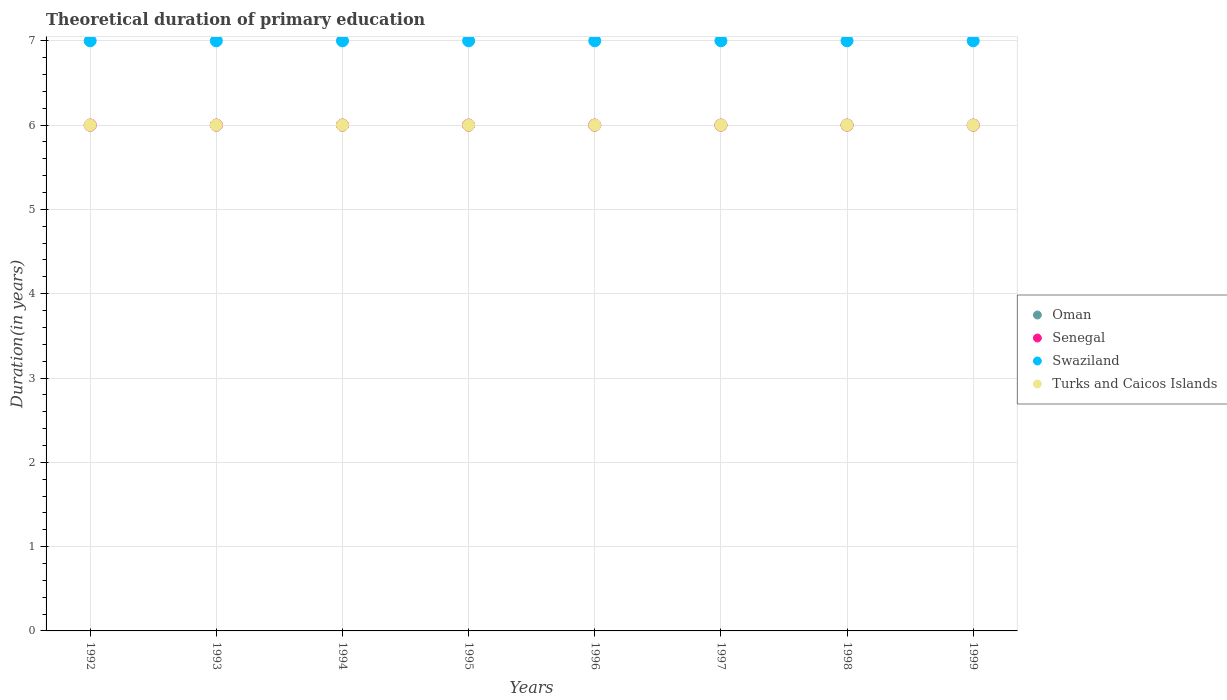What is the total theoretical duration of primary education in Turks and Caicos Islands in 1998?
Give a very brief answer. 6. Across all years, what is the maximum total theoretical duration of primary education in Swaziland?
Ensure brevity in your answer.  7. In which year was the total theoretical duration of primary education in Swaziland maximum?
Make the answer very short. 1992. What is the total total theoretical duration of primary education in Oman in the graph?
Offer a very short reply. 48. What is the difference between the total theoretical duration of primary education in Swaziland in 1992 and the total theoretical duration of primary education in Oman in 1996?
Your answer should be compact. 1. Is the total theoretical duration of primary education in Senegal in 1994 less than that in 1995?
Your answer should be compact. No. What is the difference between the highest and the second highest total theoretical duration of primary education in Senegal?
Offer a terse response. 0. What is the difference between the highest and the lowest total theoretical duration of primary education in Senegal?
Your response must be concise. 0. In how many years, is the total theoretical duration of primary education in Senegal greater than the average total theoretical duration of primary education in Senegal taken over all years?
Your answer should be compact. 0. Is the total theoretical duration of primary education in Swaziland strictly less than the total theoretical duration of primary education in Oman over the years?
Provide a short and direct response. No. How many dotlines are there?
Your answer should be compact. 4. What is the difference between two consecutive major ticks on the Y-axis?
Your answer should be very brief. 1. Are the values on the major ticks of Y-axis written in scientific E-notation?
Ensure brevity in your answer.  No. Does the graph contain grids?
Give a very brief answer. Yes. Where does the legend appear in the graph?
Ensure brevity in your answer.  Center right. How many legend labels are there?
Make the answer very short. 4. What is the title of the graph?
Make the answer very short. Theoretical duration of primary education. Does "East Asia (developing only)" appear as one of the legend labels in the graph?
Provide a short and direct response. No. What is the label or title of the X-axis?
Ensure brevity in your answer.  Years. What is the label or title of the Y-axis?
Provide a succinct answer. Duration(in years). What is the Duration(in years) in Senegal in 1992?
Offer a terse response. 6. What is the Duration(in years) in Swaziland in 1992?
Ensure brevity in your answer.  7. What is the Duration(in years) of Turks and Caicos Islands in 1992?
Ensure brevity in your answer.  6. What is the Duration(in years) of Senegal in 1993?
Make the answer very short. 6. What is the Duration(in years) in Turks and Caicos Islands in 1993?
Ensure brevity in your answer.  6. What is the Duration(in years) of Oman in 1994?
Give a very brief answer. 6. What is the Duration(in years) of Senegal in 1994?
Offer a very short reply. 6. What is the Duration(in years) in Swaziland in 1994?
Your answer should be compact. 7. What is the Duration(in years) in Turks and Caicos Islands in 1994?
Make the answer very short. 6. What is the Duration(in years) of Oman in 1995?
Your answer should be compact. 6. What is the Duration(in years) in Turks and Caicos Islands in 1996?
Your answer should be very brief. 6. What is the Duration(in years) of Oman in 1997?
Your answer should be compact. 6. What is the Duration(in years) in Swaziland in 1997?
Make the answer very short. 7. What is the Duration(in years) in Senegal in 1998?
Keep it short and to the point. 6. What is the Duration(in years) of Senegal in 1999?
Offer a very short reply. 6. Across all years, what is the maximum Duration(in years) in Oman?
Your answer should be compact. 6. Across all years, what is the maximum Duration(in years) in Swaziland?
Give a very brief answer. 7. Across all years, what is the maximum Duration(in years) of Turks and Caicos Islands?
Provide a short and direct response. 6. Across all years, what is the minimum Duration(in years) in Oman?
Your response must be concise. 6. Across all years, what is the minimum Duration(in years) of Swaziland?
Provide a short and direct response. 7. Across all years, what is the minimum Duration(in years) in Turks and Caicos Islands?
Keep it short and to the point. 6. What is the total Duration(in years) in Senegal in the graph?
Make the answer very short. 48. What is the difference between the Duration(in years) of Senegal in 1992 and that in 1993?
Your answer should be very brief. 0. What is the difference between the Duration(in years) in Turks and Caicos Islands in 1992 and that in 1993?
Give a very brief answer. 0. What is the difference between the Duration(in years) of Oman in 1992 and that in 1994?
Make the answer very short. 0. What is the difference between the Duration(in years) of Turks and Caicos Islands in 1992 and that in 1994?
Make the answer very short. 0. What is the difference between the Duration(in years) of Senegal in 1992 and that in 1995?
Keep it short and to the point. 0. What is the difference between the Duration(in years) in Swaziland in 1992 and that in 1996?
Offer a terse response. 0. What is the difference between the Duration(in years) of Turks and Caicos Islands in 1992 and that in 1996?
Offer a very short reply. 0. What is the difference between the Duration(in years) in Oman in 1992 and that in 1997?
Your answer should be very brief. 0. What is the difference between the Duration(in years) in Turks and Caicos Islands in 1992 and that in 1997?
Provide a short and direct response. 0. What is the difference between the Duration(in years) in Senegal in 1992 and that in 1998?
Provide a short and direct response. 0. What is the difference between the Duration(in years) of Senegal in 1992 and that in 1999?
Keep it short and to the point. 0. What is the difference between the Duration(in years) in Swaziland in 1992 and that in 1999?
Your answer should be compact. 0. What is the difference between the Duration(in years) in Oman in 1993 and that in 1995?
Make the answer very short. 0. What is the difference between the Duration(in years) in Senegal in 1993 and that in 1995?
Keep it short and to the point. 0. What is the difference between the Duration(in years) in Swaziland in 1993 and that in 1995?
Offer a terse response. 0. What is the difference between the Duration(in years) of Turks and Caicos Islands in 1993 and that in 1995?
Ensure brevity in your answer.  0. What is the difference between the Duration(in years) in Oman in 1993 and that in 1996?
Your response must be concise. 0. What is the difference between the Duration(in years) in Senegal in 1993 and that in 1996?
Give a very brief answer. 0. What is the difference between the Duration(in years) of Swaziland in 1993 and that in 1996?
Ensure brevity in your answer.  0. What is the difference between the Duration(in years) of Turks and Caicos Islands in 1993 and that in 1996?
Provide a short and direct response. 0. What is the difference between the Duration(in years) of Oman in 1993 and that in 1997?
Your response must be concise. 0. What is the difference between the Duration(in years) of Oman in 1993 and that in 1998?
Your answer should be very brief. 0. What is the difference between the Duration(in years) of Senegal in 1993 and that in 1998?
Your answer should be very brief. 0. What is the difference between the Duration(in years) in Swaziland in 1993 and that in 1998?
Make the answer very short. 0. What is the difference between the Duration(in years) in Turks and Caicos Islands in 1993 and that in 1998?
Provide a succinct answer. 0. What is the difference between the Duration(in years) of Oman in 1993 and that in 1999?
Give a very brief answer. 0. What is the difference between the Duration(in years) in Senegal in 1993 and that in 1999?
Make the answer very short. 0. What is the difference between the Duration(in years) of Swaziland in 1993 and that in 1999?
Offer a very short reply. 0. What is the difference between the Duration(in years) in Turks and Caicos Islands in 1993 and that in 1999?
Keep it short and to the point. 0. What is the difference between the Duration(in years) of Senegal in 1994 and that in 1995?
Make the answer very short. 0. What is the difference between the Duration(in years) of Swaziland in 1994 and that in 1995?
Provide a succinct answer. 0. What is the difference between the Duration(in years) of Oman in 1994 and that in 1996?
Ensure brevity in your answer.  0. What is the difference between the Duration(in years) in Turks and Caicos Islands in 1994 and that in 1996?
Keep it short and to the point. 0. What is the difference between the Duration(in years) of Oman in 1994 and that in 1997?
Your response must be concise. 0. What is the difference between the Duration(in years) in Senegal in 1994 and that in 1997?
Give a very brief answer. 0. What is the difference between the Duration(in years) of Swaziland in 1994 and that in 1997?
Give a very brief answer. 0. What is the difference between the Duration(in years) of Senegal in 1994 and that in 1998?
Provide a succinct answer. 0. What is the difference between the Duration(in years) of Turks and Caicos Islands in 1994 and that in 1998?
Keep it short and to the point. 0. What is the difference between the Duration(in years) of Oman in 1994 and that in 1999?
Keep it short and to the point. 0. What is the difference between the Duration(in years) of Senegal in 1994 and that in 1999?
Give a very brief answer. 0. What is the difference between the Duration(in years) of Turks and Caicos Islands in 1994 and that in 1999?
Provide a succinct answer. 0. What is the difference between the Duration(in years) of Oman in 1995 and that in 1996?
Your answer should be compact. 0. What is the difference between the Duration(in years) in Senegal in 1995 and that in 1996?
Provide a succinct answer. 0. What is the difference between the Duration(in years) of Oman in 1995 and that in 1997?
Your answer should be very brief. 0. What is the difference between the Duration(in years) in Swaziland in 1995 and that in 1997?
Offer a terse response. 0. What is the difference between the Duration(in years) in Turks and Caicos Islands in 1995 and that in 1997?
Keep it short and to the point. 0. What is the difference between the Duration(in years) of Oman in 1995 and that in 1998?
Give a very brief answer. 0. What is the difference between the Duration(in years) in Swaziland in 1995 and that in 1998?
Make the answer very short. 0. What is the difference between the Duration(in years) of Oman in 1996 and that in 1997?
Offer a very short reply. 0. What is the difference between the Duration(in years) of Senegal in 1996 and that in 1997?
Make the answer very short. 0. What is the difference between the Duration(in years) of Swaziland in 1996 and that in 1997?
Your answer should be very brief. 0. What is the difference between the Duration(in years) of Senegal in 1996 and that in 1998?
Provide a short and direct response. 0. What is the difference between the Duration(in years) in Turks and Caicos Islands in 1996 and that in 1998?
Offer a very short reply. 0. What is the difference between the Duration(in years) of Oman in 1996 and that in 1999?
Your response must be concise. 0. What is the difference between the Duration(in years) of Senegal in 1996 and that in 1999?
Give a very brief answer. 0. What is the difference between the Duration(in years) of Turks and Caicos Islands in 1996 and that in 1999?
Your answer should be compact. 0. What is the difference between the Duration(in years) of Swaziland in 1997 and that in 1998?
Your answer should be compact. 0. What is the difference between the Duration(in years) of Turks and Caicos Islands in 1997 and that in 1998?
Give a very brief answer. 0. What is the difference between the Duration(in years) in Swaziland in 1997 and that in 1999?
Your response must be concise. 0. What is the difference between the Duration(in years) in Oman in 1998 and that in 1999?
Give a very brief answer. 0. What is the difference between the Duration(in years) in Senegal in 1998 and that in 1999?
Give a very brief answer. 0. What is the difference between the Duration(in years) of Swaziland in 1998 and that in 1999?
Make the answer very short. 0. What is the difference between the Duration(in years) of Oman in 1992 and the Duration(in years) of Senegal in 1993?
Keep it short and to the point. 0. What is the difference between the Duration(in years) of Senegal in 1992 and the Duration(in years) of Turks and Caicos Islands in 1993?
Provide a succinct answer. 0. What is the difference between the Duration(in years) in Oman in 1992 and the Duration(in years) in Swaziland in 1994?
Your answer should be very brief. -1. What is the difference between the Duration(in years) in Oman in 1992 and the Duration(in years) in Turks and Caicos Islands in 1994?
Ensure brevity in your answer.  0. What is the difference between the Duration(in years) in Oman in 1992 and the Duration(in years) in Swaziland in 1995?
Ensure brevity in your answer.  -1. What is the difference between the Duration(in years) of Oman in 1992 and the Duration(in years) of Turks and Caicos Islands in 1995?
Offer a terse response. 0. What is the difference between the Duration(in years) in Senegal in 1992 and the Duration(in years) in Turks and Caicos Islands in 1995?
Your answer should be compact. 0. What is the difference between the Duration(in years) of Oman in 1992 and the Duration(in years) of Turks and Caicos Islands in 1996?
Ensure brevity in your answer.  0. What is the difference between the Duration(in years) of Senegal in 1992 and the Duration(in years) of Swaziland in 1996?
Keep it short and to the point. -1. What is the difference between the Duration(in years) in Senegal in 1992 and the Duration(in years) in Turks and Caicos Islands in 1996?
Provide a short and direct response. 0. What is the difference between the Duration(in years) in Oman in 1992 and the Duration(in years) in Turks and Caicos Islands in 1997?
Your answer should be compact. 0. What is the difference between the Duration(in years) of Senegal in 1992 and the Duration(in years) of Turks and Caicos Islands in 1997?
Offer a terse response. 0. What is the difference between the Duration(in years) of Oman in 1992 and the Duration(in years) of Senegal in 1998?
Your answer should be very brief. 0. What is the difference between the Duration(in years) in Oman in 1992 and the Duration(in years) in Swaziland in 1998?
Your answer should be compact. -1. What is the difference between the Duration(in years) of Senegal in 1992 and the Duration(in years) of Swaziland in 1998?
Give a very brief answer. -1. What is the difference between the Duration(in years) in Senegal in 1992 and the Duration(in years) in Turks and Caicos Islands in 1998?
Your answer should be compact. 0. What is the difference between the Duration(in years) in Swaziland in 1992 and the Duration(in years) in Turks and Caicos Islands in 1998?
Keep it short and to the point. 1. What is the difference between the Duration(in years) of Oman in 1992 and the Duration(in years) of Senegal in 1999?
Your answer should be very brief. 0. What is the difference between the Duration(in years) of Oman in 1992 and the Duration(in years) of Turks and Caicos Islands in 1999?
Your response must be concise. 0. What is the difference between the Duration(in years) of Swaziland in 1992 and the Duration(in years) of Turks and Caicos Islands in 1999?
Keep it short and to the point. 1. What is the difference between the Duration(in years) in Oman in 1993 and the Duration(in years) in Swaziland in 1994?
Make the answer very short. -1. What is the difference between the Duration(in years) of Senegal in 1993 and the Duration(in years) of Swaziland in 1994?
Your answer should be compact. -1. What is the difference between the Duration(in years) of Oman in 1993 and the Duration(in years) of Swaziland in 1995?
Your response must be concise. -1. What is the difference between the Duration(in years) of Oman in 1993 and the Duration(in years) of Turks and Caicos Islands in 1995?
Keep it short and to the point. 0. What is the difference between the Duration(in years) in Senegal in 1993 and the Duration(in years) in Swaziland in 1995?
Provide a succinct answer. -1. What is the difference between the Duration(in years) in Swaziland in 1993 and the Duration(in years) in Turks and Caicos Islands in 1995?
Offer a terse response. 1. What is the difference between the Duration(in years) in Senegal in 1993 and the Duration(in years) in Turks and Caicos Islands in 1996?
Provide a short and direct response. 0. What is the difference between the Duration(in years) in Oman in 1993 and the Duration(in years) in Swaziland in 1997?
Provide a short and direct response. -1. What is the difference between the Duration(in years) in Swaziland in 1993 and the Duration(in years) in Turks and Caicos Islands in 1997?
Offer a terse response. 1. What is the difference between the Duration(in years) of Oman in 1993 and the Duration(in years) of Senegal in 1998?
Offer a terse response. 0. What is the difference between the Duration(in years) in Oman in 1993 and the Duration(in years) in Turks and Caicos Islands in 1999?
Your answer should be compact. 0. What is the difference between the Duration(in years) in Senegal in 1993 and the Duration(in years) in Swaziland in 1999?
Provide a short and direct response. -1. What is the difference between the Duration(in years) in Swaziland in 1993 and the Duration(in years) in Turks and Caicos Islands in 1999?
Your answer should be compact. 1. What is the difference between the Duration(in years) in Senegal in 1994 and the Duration(in years) in Swaziland in 1995?
Keep it short and to the point. -1. What is the difference between the Duration(in years) of Oman in 1994 and the Duration(in years) of Senegal in 1996?
Keep it short and to the point. 0. What is the difference between the Duration(in years) in Oman in 1994 and the Duration(in years) in Swaziland in 1996?
Your answer should be compact. -1. What is the difference between the Duration(in years) of Senegal in 1994 and the Duration(in years) of Turks and Caicos Islands in 1996?
Your answer should be compact. 0. What is the difference between the Duration(in years) of Oman in 1994 and the Duration(in years) of Senegal in 1997?
Your answer should be very brief. 0. What is the difference between the Duration(in years) in Oman in 1994 and the Duration(in years) in Swaziland in 1997?
Your answer should be very brief. -1. What is the difference between the Duration(in years) of Oman in 1994 and the Duration(in years) of Turks and Caicos Islands in 1997?
Offer a terse response. 0. What is the difference between the Duration(in years) of Senegal in 1994 and the Duration(in years) of Swaziland in 1997?
Provide a succinct answer. -1. What is the difference between the Duration(in years) of Senegal in 1994 and the Duration(in years) of Turks and Caicos Islands in 1997?
Ensure brevity in your answer.  0. What is the difference between the Duration(in years) of Swaziland in 1994 and the Duration(in years) of Turks and Caicos Islands in 1997?
Ensure brevity in your answer.  1. What is the difference between the Duration(in years) in Oman in 1994 and the Duration(in years) in Swaziland in 1998?
Keep it short and to the point. -1. What is the difference between the Duration(in years) in Swaziland in 1994 and the Duration(in years) in Turks and Caicos Islands in 1998?
Provide a short and direct response. 1. What is the difference between the Duration(in years) of Oman in 1994 and the Duration(in years) of Senegal in 1999?
Your answer should be compact. 0. What is the difference between the Duration(in years) in Senegal in 1994 and the Duration(in years) in Turks and Caicos Islands in 1999?
Your answer should be compact. 0. What is the difference between the Duration(in years) in Swaziland in 1994 and the Duration(in years) in Turks and Caicos Islands in 1999?
Your response must be concise. 1. What is the difference between the Duration(in years) of Oman in 1995 and the Duration(in years) of Senegal in 1996?
Your answer should be very brief. 0. What is the difference between the Duration(in years) in Senegal in 1995 and the Duration(in years) in Swaziland in 1996?
Ensure brevity in your answer.  -1. What is the difference between the Duration(in years) in Senegal in 1995 and the Duration(in years) in Turks and Caicos Islands in 1996?
Keep it short and to the point. 0. What is the difference between the Duration(in years) in Swaziland in 1995 and the Duration(in years) in Turks and Caicos Islands in 1997?
Give a very brief answer. 1. What is the difference between the Duration(in years) in Oman in 1995 and the Duration(in years) in Swaziland in 1998?
Your answer should be very brief. -1. What is the difference between the Duration(in years) of Oman in 1995 and the Duration(in years) of Turks and Caicos Islands in 1998?
Provide a short and direct response. 0. What is the difference between the Duration(in years) in Senegal in 1995 and the Duration(in years) in Swaziland in 1998?
Your answer should be very brief. -1. What is the difference between the Duration(in years) in Senegal in 1995 and the Duration(in years) in Turks and Caicos Islands in 1998?
Give a very brief answer. 0. What is the difference between the Duration(in years) in Swaziland in 1995 and the Duration(in years) in Turks and Caicos Islands in 1998?
Ensure brevity in your answer.  1. What is the difference between the Duration(in years) in Oman in 1995 and the Duration(in years) in Senegal in 1999?
Your response must be concise. 0. What is the difference between the Duration(in years) of Oman in 1995 and the Duration(in years) of Swaziland in 1999?
Your answer should be compact. -1. What is the difference between the Duration(in years) of Senegal in 1995 and the Duration(in years) of Swaziland in 1999?
Your answer should be compact. -1. What is the difference between the Duration(in years) in Swaziland in 1995 and the Duration(in years) in Turks and Caicos Islands in 1999?
Offer a terse response. 1. What is the difference between the Duration(in years) of Oman in 1996 and the Duration(in years) of Senegal in 1997?
Ensure brevity in your answer.  0. What is the difference between the Duration(in years) of Oman in 1996 and the Duration(in years) of Swaziland in 1997?
Provide a succinct answer. -1. What is the difference between the Duration(in years) in Oman in 1996 and the Duration(in years) in Turks and Caicos Islands in 1997?
Ensure brevity in your answer.  0. What is the difference between the Duration(in years) of Senegal in 1996 and the Duration(in years) of Swaziland in 1997?
Provide a short and direct response. -1. What is the difference between the Duration(in years) in Senegal in 1996 and the Duration(in years) in Turks and Caicos Islands in 1997?
Your answer should be very brief. 0. What is the difference between the Duration(in years) of Swaziland in 1996 and the Duration(in years) of Turks and Caicos Islands in 1997?
Offer a very short reply. 1. What is the difference between the Duration(in years) of Oman in 1996 and the Duration(in years) of Turks and Caicos Islands in 1998?
Make the answer very short. 0. What is the difference between the Duration(in years) of Senegal in 1996 and the Duration(in years) of Turks and Caicos Islands in 1998?
Offer a terse response. 0. What is the difference between the Duration(in years) in Swaziland in 1996 and the Duration(in years) in Turks and Caicos Islands in 1998?
Your answer should be compact. 1. What is the difference between the Duration(in years) of Swaziland in 1996 and the Duration(in years) of Turks and Caicos Islands in 1999?
Provide a succinct answer. 1. What is the difference between the Duration(in years) in Senegal in 1997 and the Duration(in years) in Turks and Caicos Islands in 1998?
Your response must be concise. 0. What is the difference between the Duration(in years) of Swaziland in 1997 and the Duration(in years) of Turks and Caicos Islands in 1998?
Provide a short and direct response. 1. What is the difference between the Duration(in years) in Oman in 1997 and the Duration(in years) in Senegal in 1999?
Make the answer very short. 0. What is the difference between the Duration(in years) in Oman in 1997 and the Duration(in years) in Swaziland in 1999?
Provide a succinct answer. -1. What is the difference between the Duration(in years) of Oman in 1997 and the Duration(in years) of Turks and Caicos Islands in 1999?
Provide a short and direct response. 0. What is the difference between the Duration(in years) in Senegal in 1997 and the Duration(in years) in Turks and Caicos Islands in 1999?
Your answer should be compact. 0. What is the difference between the Duration(in years) in Swaziland in 1997 and the Duration(in years) in Turks and Caicos Islands in 1999?
Your answer should be very brief. 1. What is the difference between the Duration(in years) of Oman in 1998 and the Duration(in years) of Senegal in 1999?
Provide a succinct answer. 0. What is the difference between the Duration(in years) in Oman in 1998 and the Duration(in years) in Swaziland in 1999?
Provide a succinct answer. -1. What is the difference between the Duration(in years) in Oman in 1998 and the Duration(in years) in Turks and Caicos Islands in 1999?
Give a very brief answer. 0. What is the average Duration(in years) in Senegal per year?
Offer a very short reply. 6. In the year 1992, what is the difference between the Duration(in years) of Oman and Duration(in years) of Swaziland?
Keep it short and to the point. -1. In the year 1992, what is the difference between the Duration(in years) in Senegal and Duration(in years) in Swaziland?
Make the answer very short. -1. In the year 1993, what is the difference between the Duration(in years) in Oman and Duration(in years) in Swaziland?
Provide a short and direct response. -1. In the year 1993, what is the difference between the Duration(in years) of Senegal and Duration(in years) of Turks and Caicos Islands?
Give a very brief answer. 0. In the year 1993, what is the difference between the Duration(in years) in Swaziland and Duration(in years) in Turks and Caicos Islands?
Make the answer very short. 1. In the year 1994, what is the difference between the Duration(in years) of Oman and Duration(in years) of Senegal?
Your answer should be compact. 0. In the year 1994, what is the difference between the Duration(in years) in Oman and Duration(in years) in Swaziland?
Provide a short and direct response. -1. In the year 1994, what is the difference between the Duration(in years) of Oman and Duration(in years) of Turks and Caicos Islands?
Ensure brevity in your answer.  0. In the year 1994, what is the difference between the Duration(in years) in Senegal and Duration(in years) in Swaziland?
Offer a terse response. -1. In the year 1995, what is the difference between the Duration(in years) of Oman and Duration(in years) of Turks and Caicos Islands?
Your answer should be very brief. 0. In the year 1995, what is the difference between the Duration(in years) of Senegal and Duration(in years) of Turks and Caicos Islands?
Offer a very short reply. 0. In the year 1996, what is the difference between the Duration(in years) of Oman and Duration(in years) of Swaziland?
Provide a short and direct response. -1. In the year 1996, what is the difference between the Duration(in years) in Oman and Duration(in years) in Turks and Caicos Islands?
Offer a very short reply. 0. In the year 1996, what is the difference between the Duration(in years) in Senegal and Duration(in years) in Turks and Caicos Islands?
Your answer should be very brief. 0. In the year 1996, what is the difference between the Duration(in years) in Swaziland and Duration(in years) in Turks and Caicos Islands?
Your response must be concise. 1. In the year 1997, what is the difference between the Duration(in years) in Oman and Duration(in years) in Senegal?
Make the answer very short. 0. In the year 1997, what is the difference between the Duration(in years) in Senegal and Duration(in years) in Swaziland?
Ensure brevity in your answer.  -1. In the year 1998, what is the difference between the Duration(in years) in Oman and Duration(in years) in Senegal?
Provide a short and direct response. 0. In the year 1998, what is the difference between the Duration(in years) in Senegal and Duration(in years) in Swaziland?
Provide a succinct answer. -1. In the year 1999, what is the difference between the Duration(in years) of Senegal and Duration(in years) of Swaziland?
Keep it short and to the point. -1. In the year 1999, what is the difference between the Duration(in years) of Senegal and Duration(in years) of Turks and Caicos Islands?
Your answer should be very brief. 0. What is the ratio of the Duration(in years) of Oman in 1992 to that in 1993?
Make the answer very short. 1. What is the ratio of the Duration(in years) of Oman in 1992 to that in 1994?
Provide a succinct answer. 1. What is the ratio of the Duration(in years) of Turks and Caicos Islands in 1992 to that in 1994?
Make the answer very short. 1. What is the ratio of the Duration(in years) in Senegal in 1992 to that in 1995?
Your answer should be compact. 1. What is the ratio of the Duration(in years) in Turks and Caicos Islands in 1992 to that in 1995?
Your response must be concise. 1. What is the ratio of the Duration(in years) of Oman in 1992 to that in 1996?
Keep it short and to the point. 1. What is the ratio of the Duration(in years) in Senegal in 1992 to that in 1996?
Your answer should be compact. 1. What is the ratio of the Duration(in years) in Swaziland in 1992 to that in 1996?
Offer a terse response. 1. What is the ratio of the Duration(in years) in Turks and Caicos Islands in 1992 to that in 1996?
Your answer should be very brief. 1. What is the ratio of the Duration(in years) of Oman in 1992 to that in 1997?
Your answer should be very brief. 1. What is the ratio of the Duration(in years) of Senegal in 1992 to that in 1997?
Offer a terse response. 1. What is the ratio of the Duration(in years) of Swaziland in 1992 to that in 1997?
Offer a very short reply. 1. What is the ratio of the Duration(in years) in Swaziland in 1992 to that in 1998?
Offer a very short reply. 1. What is the ratio of the Duration(in years) of Turks and Caicos Islands in 1992 to that in 1998?
Make the answer very short. 1. What is the ratio of the Duration(in years) in Senegal in 1992 to that in 1999?
Your answer should be very brief. 1. What is the ratio of the Duration(in years) in Swaziland in 1992 to that in 1999?
Make the answer very short. 1. What is the ratio of the Duration(in years) of Senegal in 1993 to that in 1994?
Your answer should be compact. 1. What is the ratio of the Duration(in years) in Swaziland in 1993 to that in 1994?
Your answer should be compact. 1. What is the ratio of the Duration(in years) in Oman in 1993 to that in 1995?
Your answer should be compact. 1. What is the ratio of the Duration(in years) in Senegal in 1993 to that in 1995?
Make the answer very short. 1. What is the ratio of the Duration(in years) of Swaziland in 1993 to that in 1995?
Offer a terse response. 1. What is the ratio of the Duration(in years) in Swaziland in 1993 to that in 1996?
Keep it short and to the point. 1. What is the ratio of the Duration(in years) in Oman in 1993 to that in 1997?
Your answer should be very brief. 1. What is the ratio of the Duration(in years) in Swaziland in 1993 to that in 1997?
Give a very brief answer. 1. What is the ratio of the Duration(in years) of Oman in 1993 to that in 1998?
Make the answer very short. 1. What is the ratio of the Duration(in years) of Senegal in 1993 to that in 1998?
Keep it short and to the point. 1. What is the ratio of the Duration(in years) of Oman in 1993 to that in 1999?
Provide a succinct answer. 1. What is the ratio of the Duration(in years) of Senegal in 1993 to that in 1999?
Offer a very short reply. 1. What is the ratio of the Duration(in years) of Swaziland in 1993 to that in 1999?
Keep it short and to the point. 1. What is the ratio of the Duration(in years) of Turks and Caicos Islands in 1993 to that in 1999?
Keep it short and to the point. 1. What is the ratio of the Duration(in years) in Oman in 1994 to that in 1995?
Make the answer very short. 1. What is the ratio of the Duration(in years) of Swaziland in 1994 to that in 1995?
Your answer should be very brief. 1. What is the ratio of the Duration(in years) of Turks and Caicos Islands in 1994 to that in 1995?
Provide a short and direct response. 1. What is the ratio of the Duration(in years) in Senegal in 1994 to that in 1996?
Ensure brevity in your answer.  1. What is the ratio of the Duration(in years) of Swaziland in 1994 to that in 1996?
Your answer should be compact. 1. What is the ratio of the Duration(in years) in Turks and Caicos Islands in 1994 to that in 1996?
Your response must be concise. 1. What is the ratio of the Duration(in years) of Oman in 1994 to that in 1997?
Offer a terse response. 1. What is the ratio of the Duration(in years) of Turks and Caicos Islands in 1994 to that in 1997?
Provide a succinct answer. 1. What is the ratio of the Duration(in years) in Senegal in 1994 to that in 1998?
Your answer should be very brief. 1. What is the ratio of the Duration(in years) of Swaziland in 1994 to that in 1998?
Ensure brevity in your answer.  1. What is the ratio of the Duration(in years) of Turks and Caicos Islands in 1994 to that in 1998?
Provide a succinct answer. 1. What is the ratio of the Duration(in years) of Oman in 1994 to that in 1999?
Keep it short and to the point. 1. What is the ratio of the Duration(in years) of Turks and Caicos Islands in 1994 to that in 1999?
Offer a terse response. 1. What is the ratio of the Duration(in years) in Senegal in 1995 to that in 1996?
Provide a short and direct response. 1. What is the ratio of the Duration(in years) of Turks and Caicos Islands in 1995 to that in 1996?
Offer a very short reply. 1. What is the ratio of the Duration(in years) in Oman in 1995 to that in 1997?
Ensure brevity in your answer.  1. What is the ratio of the Duration(in years) in Senegal in 1995 to that in 1997?
Provide a short and direct response. 1. What is the ratio of the Duration(in years) of Turks and Caicos Islands in 1995 to that in 1997?
Your answer should be compact. 1. What is the ratio of the Duration(in years) in Turks and Caicos Islands in 1995 to that in 1998?
Your response must be concise. 1. What is the ratio of the Duration(in years) in Swaziland in 1995 to that in 1999?
Your response must be concise. 1. What is the ratio of the Duration(in years) of Senegal in 1996 to that in 1997?
Make the answer very short. 1. What is the ratio of the Duration(in years) in Swaziland in 1996 to that in 1997?
Keep it short and to the point. 1. What is the ratio of the Duration(in years) in Oman in 1996 to that in 1998?
Your answer should be compact. 1. What is the ratio of the Duration(in years) of Senegal in 1996 to that in 1998?
Ensure brevity in your answer.  1. What is the ratio of the Duration(in years) of Turks and Caicos Islands in 1996 to that in 1998?
Provide a succinct answer. 1. What is the ratio of the Duration(in years) of Oman in 1996 to that in 1999?
Give a very brief answer. 1. What is the ratio of the Duration(in years) of Senegal in 1996 to that in 1999?
Your answer should be compact. 1. What is the ratio of the Duration(in years) in Senegal in 1997 to that in 1998?
Keep it short and to the point. 1. What is the ratio of the Duration(in years) of Swaziland in 1997 to that in 1998?
Your answer should be very brief. 1. What is the ratio of the Duration(in years) of Swaziland in 1997 to that in 1999?
Give a very brief answer. 1. What is the ratio of the Duration(in years) of Oman in 1998 to that in 1999?
Your answer should be compact. 1. What is the ratio of the Duration(in years) in Swaziland in 1998 to that in 1999?
Make the answer very short. 1. What is the ratio of the Duration(in years) in Turks and Caicos Islands in 1998 to that in 1999?
Ensure brevity in your answer.  1. What is the difference between the highest and the second highest Duration(in years) of Swaziland?
Give a very brief answer. 0. What is the difference between the highest and the second highest Duration(in years) in Turks and Caicos Islands?
Provide a succinct answer. 0. What is the difference between the highest and the lowest Duration(in years) of Oman?
Ensure brevity in your answer.  0. What is the difference between the highest and the lowest Duration(in years) in Swaziland?
Provide a succinct answer. 0. What is the difference between the highest and the lowest Duration(in years) in Turks and Caicos Islands?
Your answer should be compact. 0. 